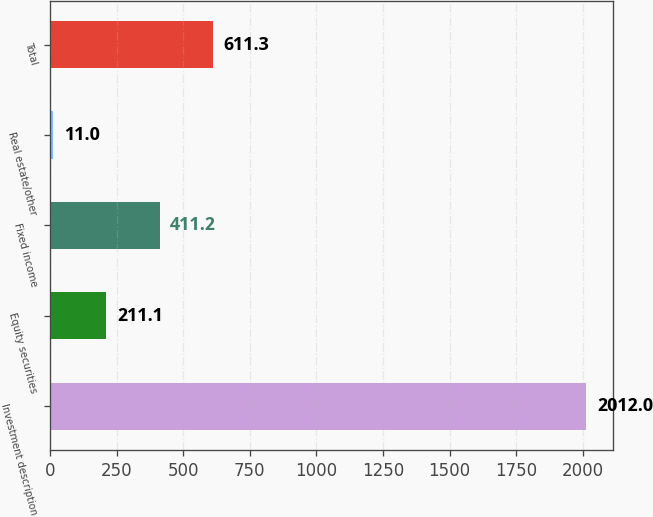Convert chart. <chart><loc_0><loc_0><loc_500><loc_500><bar_chart><fcel>Investment description<fcel>Equity securities<fcel>Fixed income<fcel>Real estate/other<fcel>Total<nl><fcel>2012<fcel>211.1<fcel>411.2<fcel>11<fcel>611.3<nl></chart> 